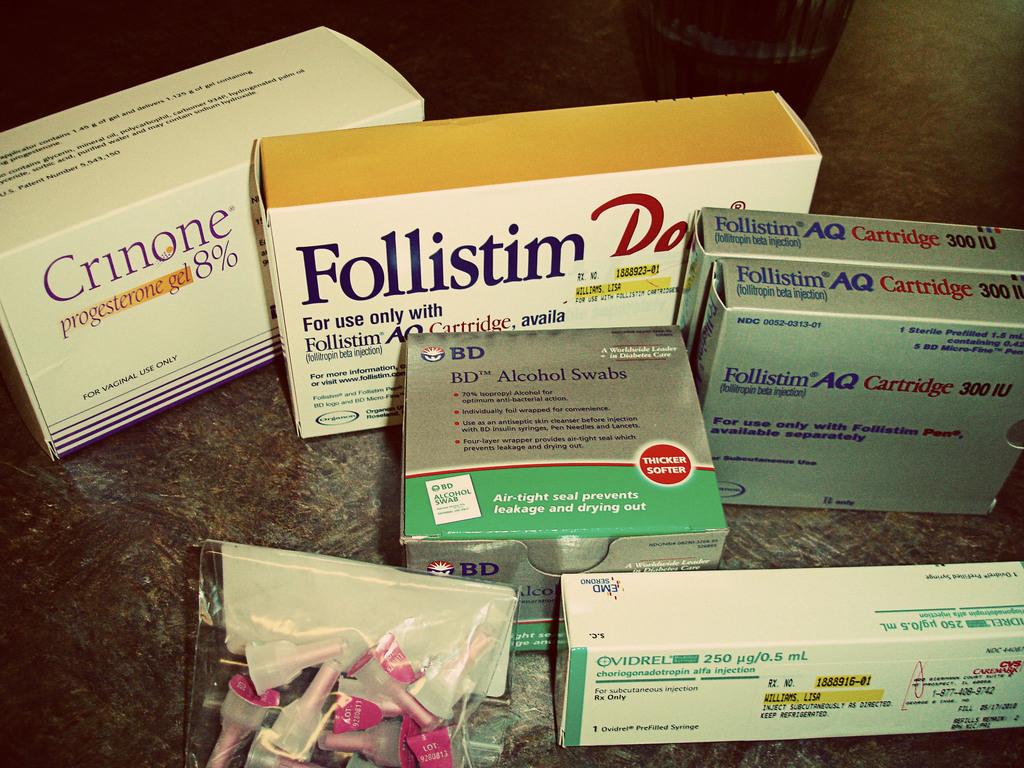What percentage of progesterone is in the crinone?
Provide a succinct answer. 8. What is the medication that starts with the letter f?
Offer a terse response. Follistim. 